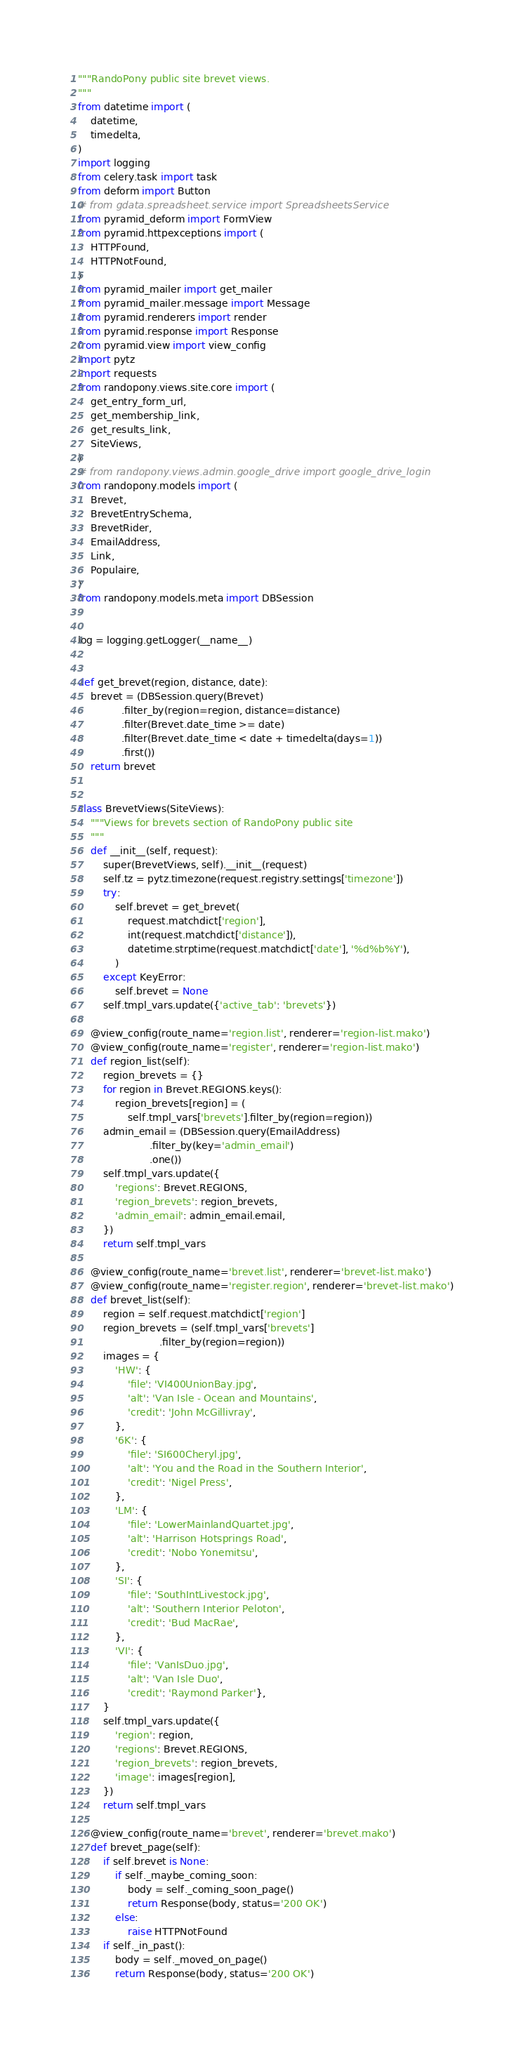<code> <loc_0><loc_0><loc_500><loc_500><_Python_>"""RandoPony public site brevet views.
"""
from datetime import (
    datetime,
    timedelta,
)
import logging
from celery.task import task
from deform import Button
# from gdata.spreadsheet.service import SpreadsheetsService
from pyramid_deform import FormView
from pyramid.httpexceptions import (
    HTTPFound,
    HTTPNotFound,
)
from pyramid_mailer import get_mailer
from pyramid_mailer.message import Message
from pyramid.renderers import render
from pyramid.response import Response
from pyramid.view import view_config
import pytz
import requests
from randopony.views.site.core import (
    get_entry_form_url,
    get_membership_link,
    get_results_link,
    SiteViews,
)
# from randopony.views.admin.google_drive import google_drive_login
from randopony.models import (
    Brevet,
    BrevetEntrySchema,
    BrevetRider,
    EmailAddress,
    Link,
    Populaire,
)
from randopony.models.meta import DBSession


log = logging.getLogger(__name__)


def get_brevet(region, distance, date):
    brevet = (DBSession.query(Brevet)
              .filter_by(region=region, distance=distance)
              .filter(Brevet.date_time >= date)
              .filter(Brevet.date_time < date + timedelta(days=1))
              .first())
    return brevet


class BrevetViews(SiteViews):
    """Views for brevets section of RandoPony public site
    """
    def __init__(self, request):
        super(BrevetViews, self).__init__(request)
        self.tz = pytz.timezone(request.registry.settings['timezone'])
        try:
            self.brevet = get_brevet(
                request.matchdict['region'],
                int(request.matchdict['distance']),
                datetime.strptime(request.matchdict['date'], '%d%b%Y'),
            )
        except KeyError:
            self.brevet = None
        self.tmpl_vars.update({'active_tab': 'brevets'})

    @view_config(route_name='region.list', renderer='region-list.mako')
    @view_config(route_name='register', renderer='region-list.mako')
    def region_list(self):
        region_brevets = {}
        for region in Brevet.REGIONS.keys():
            region_brevets[region] = (
                self.tmpl_vars['brevets'].filter_by(region=region))
        admin_email = (DBSession.query(EmailAddress)
                       .filter_by(key='admin_email')
                       .one())
        self.tmpl_vars.update({
            'regions': Brevet.REGIONS,
            'region_brevets': region_brevets,
            'admin_email': admin_email.email,
        })
        return self.tmpl_vars

    @view_config(route_name='brevet.list', renderer='brevet-list.mako')
    @view_config(route_name='register.region', renderer='brevet-list.mako')
    def brevet_list(self):
        region = self.request.matchdict['region']
        region_brevets = (self.tmpl_vars['brevets']
                          .filter_by(region=region))
        images = {
            'HW': {
                'file': 'VI400UnionBay.jpg',
                'alt': 'Van Isle - Ocean and Mountains',
                'credit': 'John McGillivray',
            },
            '6K': {
                'file': 'SI600Cheryl.jpg',
                'alt': 'You and the Road in the Southern Interior',
                'credit': 'Nigel Press',
            },
            'LM': {
                'file': 'LowerMainlandQuartet.jpg',
                'alt': 'Harrison Hotsprings Road',
                'credit': 'Nobo Yonemitsu',
            },
            'SI': {
                'file': 'SouthIntLivestock.jpg',
                'alt': 'Southern Interior Peloton',
                'credit': 'Bud MacRae',
            },
            'VI': {
                'file': 'VanIsDuo.jpg',
                'alt': 'Van Isle Duo',
                'credit': 'Raymond Parker'},
        }
        self.tmpl_vars.update({
            'region': region,
            'regions': Brevet.REGIONS,
            'region_brevets': region_brevets,
            'image': images[region],
        })
        return self.tmpl_vars

    @view_config(route_name='brevet', renderer='brevet.mako')
    def brevet_page(self):
        if self.brevet is None:
            if self._maybe_coming_soon:
                body = self._coming_soon_page()
                return Response(body, status='200 OK')
            else:
                raise HTTPNotFound
        if self._in_past():
            body = self._moved_on_page()
            return Response(body, status='200 OK')</code> 